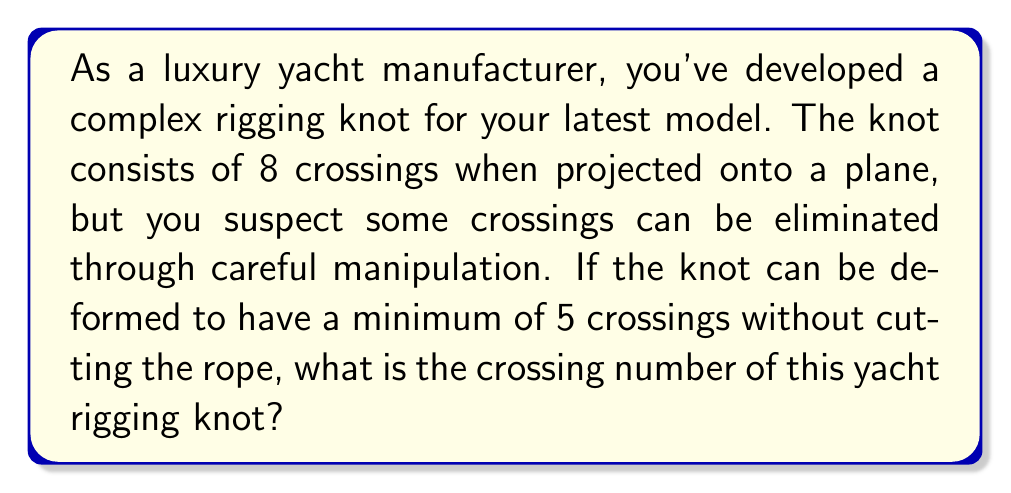Can you solve this math problem? To determine the crossing number of the yacht rigging knot, we need to follow these steps:

1. Understand the definition: The crossing number of a knot is the minimum number of crossings in any diagram of the knot.

2. Analyze the given information:
   - The initial projection shows 8 crossings.
   - The knot can be deformed to have 5 crossings.

3. Consider the Reidemeister moves:
   Reidemeister moves are operations that can be performed on a knot diagram without changing the knot type. There are three types of moves:
   - Type I: Twist or untwist a strand
   - Type II: Move one strand completely over another
   - Type III: Move a strand over or under a crossing

4. Apply the principle of minimality:
   The crossing number is the smallest number of crossings that can be achieved through any combination of Reidemeister moves.

5. Conclude:
   Since the knot can be deformed to have 5 crossings, and this is stated as the minimum, we can conclude that 5 is the crossing number of the knot.

6. Verify:
   It's important to note that proving a crossing number is typically a complex process. In this case, we're given that 5 is the minimum, but in real-world scenarios, this would require rigorous proof.

Therefore, the crossing number of the complex yacht rigging knot is 5.
Answer: 5 